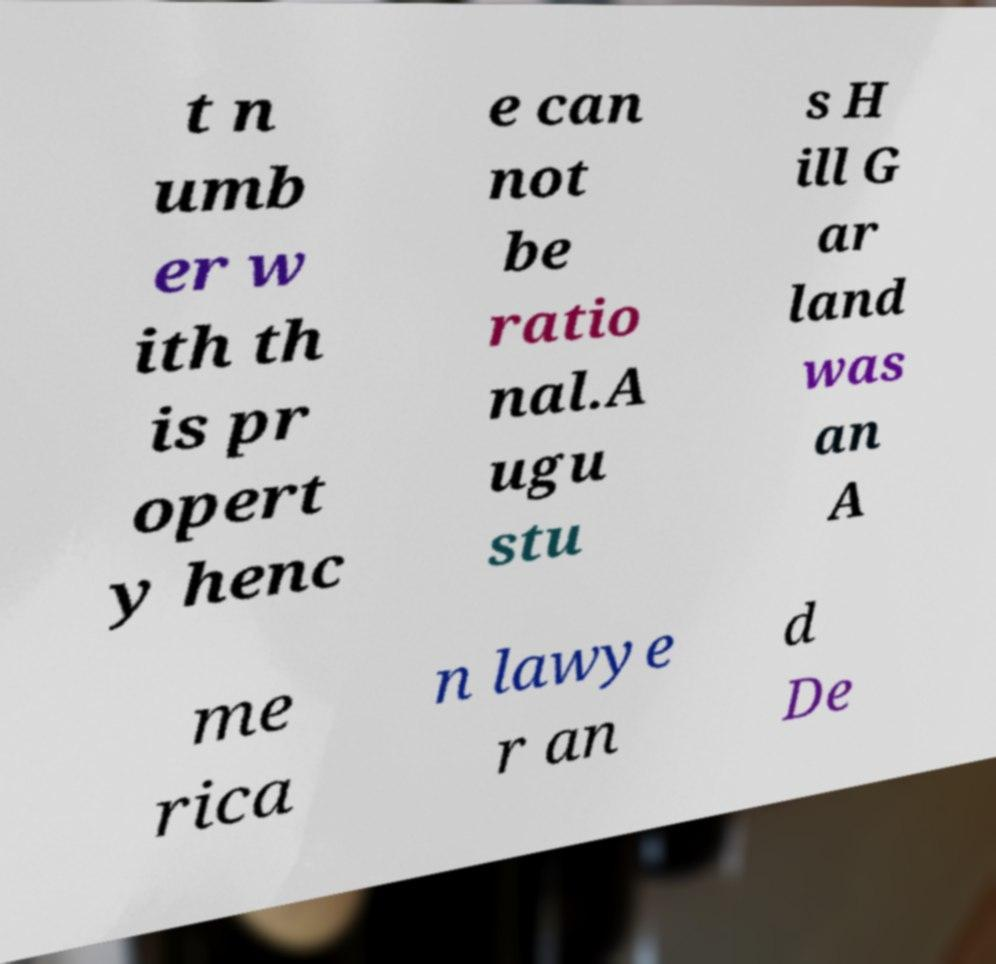Could you extract and type out the text from this image? t n umb er w ith th is pr opert y henc e can not be ratio nal.A ugu stu s H ill G ar land was an A me rica n lawye r an d De 